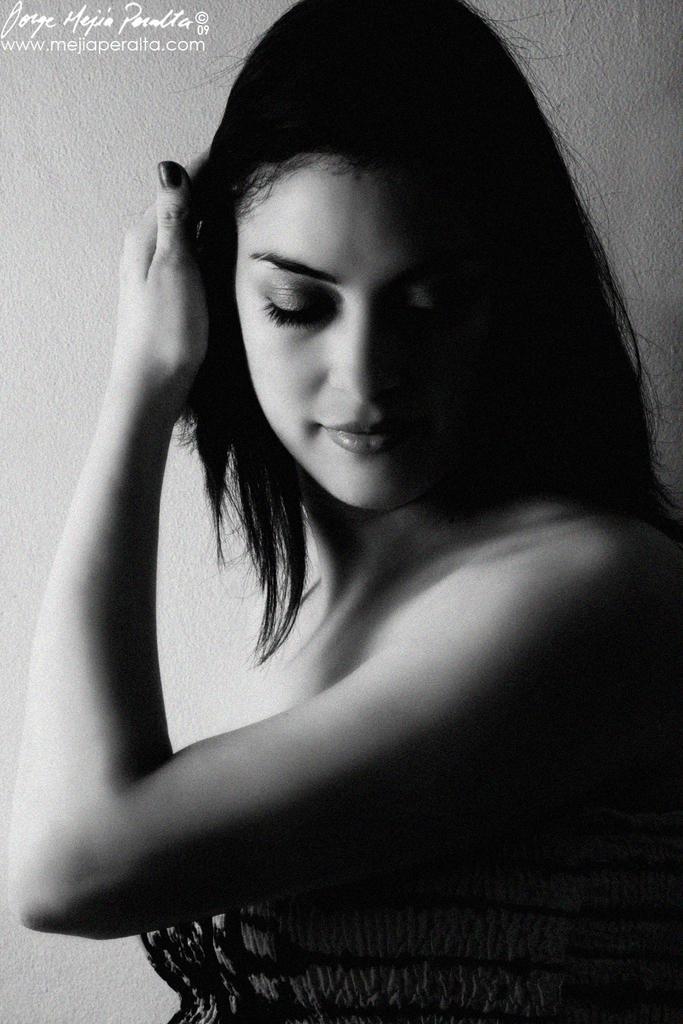Describe this image in one or two sentences. This is a black and white image. In the center of the image we can see women. In the background there is wall. 